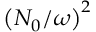Convert formula to latex. <formula><loc_0><loc_0><loc_500><loc_500>\left ( N _ { 0 } / \omega \right ) ^ { 2 }</formula> 